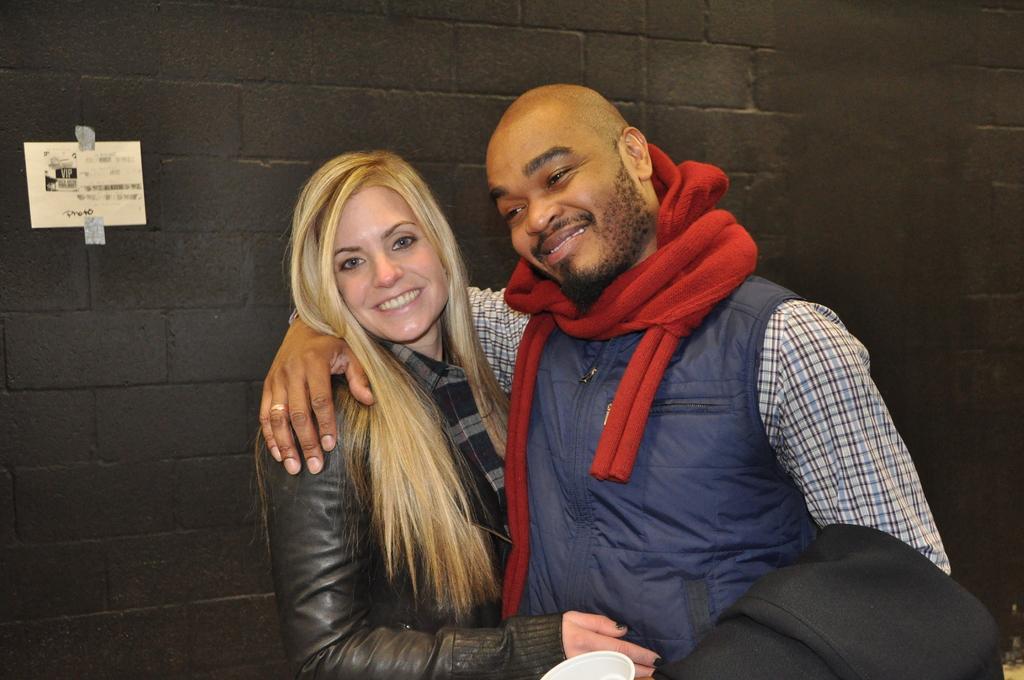In one or two sentences, can you explain what this image depicts? In this picture there is a woman who is wearing jacket and shirt. She is standing near to the black wall. Beside her there is a man who is wearing scarf, jacket, shirt and holding a jacket and cup. On the left there is a paper were attached on the wall. 